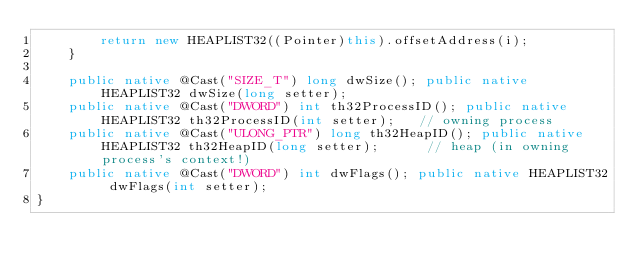<code> <loc_0><loc_0><loc_500><loc_500><_Java_>        return new HEAPLIST32((Pointer)this).offsetAddress(i);
    }

    public native @Cast("SIZE_T") long dwSize(); public native HEAPLIST32 dwSize(long setter);
    public native @Cast("DWORD") int th32ProcessID(); public native HEAPLIST32 th32ProcessID(int setter);   // owning process
    public native @Cast("ULONG_PTR") long th32HeapID(); public native HEAPLIST32 th32HeapID(long setter);      // heap (in owning process's context!)
    public native @Cast("DWORD") int dwFlags(); public native HEAPLIST32 dwFlags(int setter);
}
</code> 